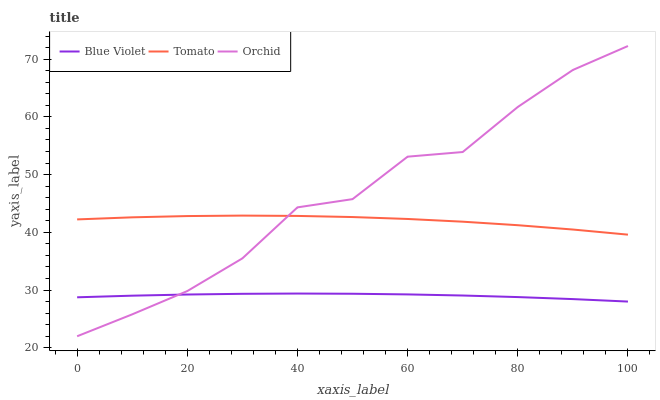Does Blue Violet have the minimum area under the curve?
Answer yes or no. Yes. Does Orchid have the maximum area under the curve?
Answer yes or no. Yes. Does Orchid have the minimum area under the curve?
Answer yes or no. No. Does Blue Violet have the maximum area under the curve?
Answer yes or no. No. Is Blue Violet the smoothest?
Answer yes or no. Yes. Is Orchid the roughest?
Answer yes or no. Yes. Is Orchid the smoothest?
Answer yes or no. No. Is Blue Violet the roughest?
Answer yes or no. No. Does Orchid have the lowest value?
Answer yes or no. Yes. Does Blue Violet have the lowest value?
Answer yes or no. No. Does Orchid have the highest value?
Answer yes or no. Yes. Does Blue Violet have the highest value?
Answer yes or no. No. Is Blue Violet less than Tomato?
Answer yes or no. Yes. Is Tomato greater than Blue Violet?
Answer yes or no. Yes. Does Orchid intersect Blue Violet?
Answer yes or no. Yes. Is Orchid less than Blue Violet?
Answer yes or no. No. Is Orchid greater than Blue Violet?
Answer yes or no. No. Does Blue Violet intersect Tomato?
Answer yes or no. No. 